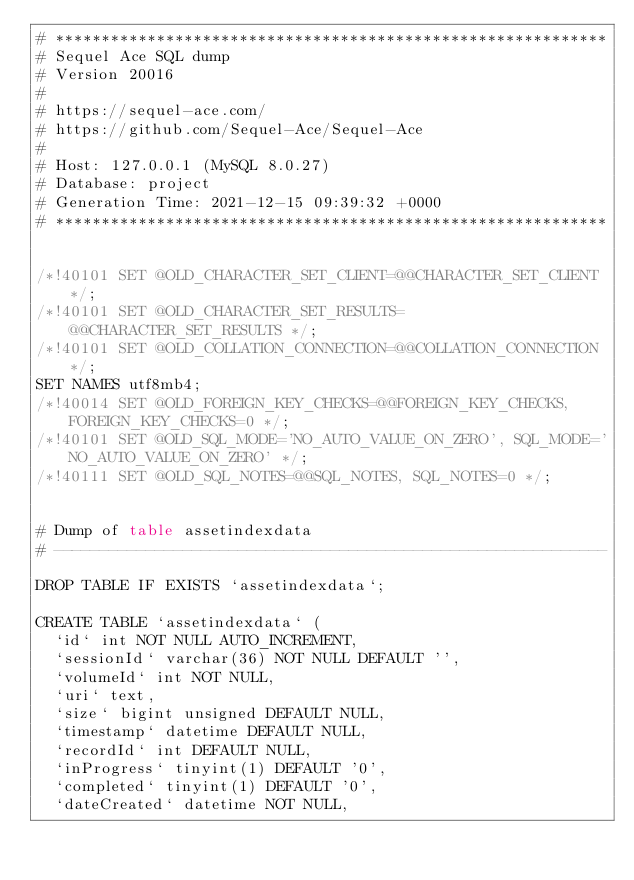Convert code to text. <code><loc_0><loc_0><loc_500><loc_500><_SQL_># ************************************************************
# Sequel Ace SQL dump
# Version 20016
#
# https://sequel-ace.com/
# https://github.com/Sequel-Ace/Sequel-Ace
#
# Host: 127.0.0.1 (MySQL 8.0.27)
# Database: project
# Generation Time: 2021-12-15 09:39:32 +0000
# ************************************************************


/*!40101 SET @OLD_CHARACTER_SET_CLIENT=@@CHARACTER_SET_CLIENT */;
/*!40101 SET @OLD_CHARACTER_SET_RESULTS=@@CHARACTER_SET_RESULTS */;
/*!40101 SET @OLD_COLLATION_CONNECTION=@@COLLATION_CONNECTION */;
SET NAMES utf8mb4;
/*!40014 SET @OLD_FOREIGN_KEY_CHECKS=@@FOREIGN_KEY_CHECKS, FOREIGN_KEY_CHECKS=0 */;
/*!40101 SET @OLD_SQL_MODE='NO_AUTO_VALUE_ON_ZERO', SQL_MODE='NO_AUTO_VALUE_ON_ZERO' */;
/*!40111 SET @OLD_SQL_NOTES=@@SQL_NOTES, SQL_NOTES=0 */;


# Dump of table assetindexdata
# ------------------------------------------------------------

DROP TABLE IF EXISTS `assetindexdata`;

CREATE TABLE `assetindexdata` (
  `id` int NOT NULL AUTO_INCREMENT,
  `sessionId` varchar(36) NOT NULL DEFAULT '',
  `volumeId` int NOT NULL,
  `uri` text,
  `size` bigint unsigned DEFAULT NULL,
  `timestamp` datetime DEFAULT NULL,
  `recordId` int DEFAULT NULL,
  `inProgress` tinyint(1) DEFAULT '0',
  `completed` tinyint(1) DEFAULT '0',
  `dateCreated` datetime NOT NULL,</code> 